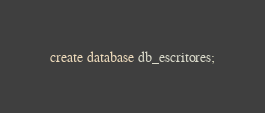Convert code to text. <code><loc_0><loc_0><loc_500><loc_500><_SQL_>create database db_escritores;
</code> 